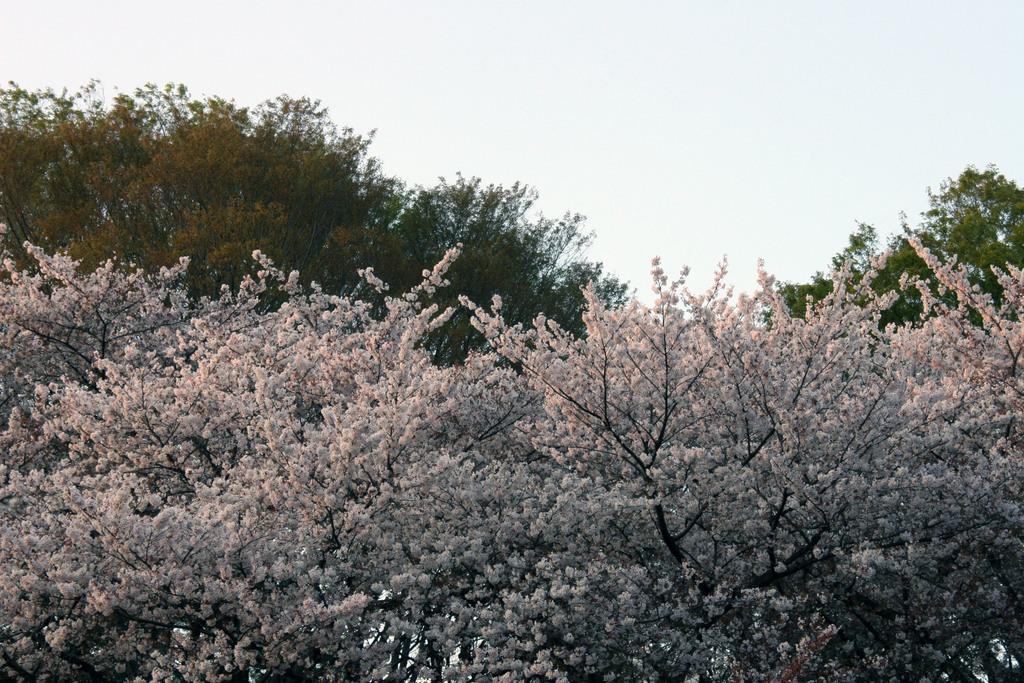How would you summarize this image in a sentence or two? In this image there are few trees having flowers. Behind there are few trees having leaves. Top of the image there is sky. 